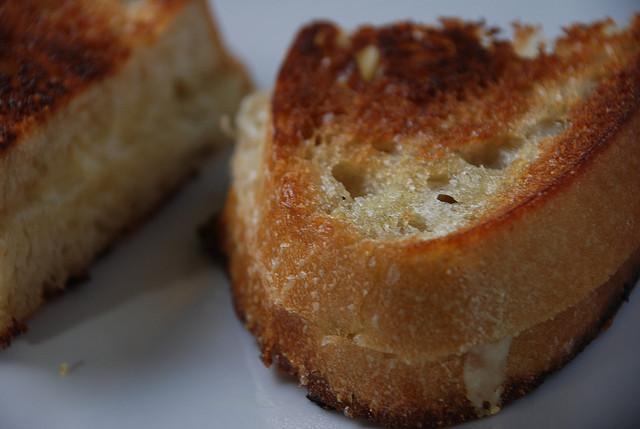How many sandwiches are there?
Give a very brief answer. 2. 